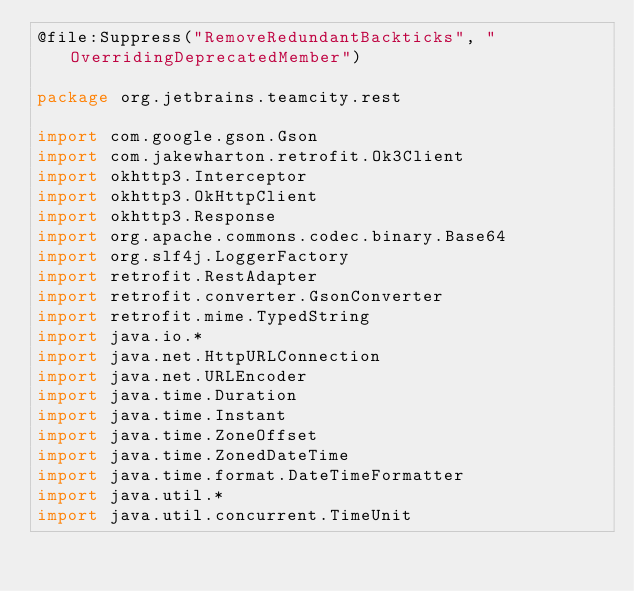<code> <loc_0><loc_0><loc_500><loc_500><_Kotlin_>@file:Suppress("RemoveRedundantBackticks", "OverridingDeprecatedMember")

package org.jetbrains.teamcity.rest

import com.google.gson.Gson
import com.jakewharton.retrofit.Ok3Client
import okhttp3.Interceptor
import okhttp3.OkHttpClient
import okhttp3.Response
import org.apache.commons.codec.binary.Base64
import org.slf4j.LoggerFactory
import retrofit.RestAdapter
import retrofit.converter.GsonConverter
import retrofit.mime.TypedString
import java.io.*
import java.net.HttpURLConnection
import java.net.URLEncoder
import java.time.Duration
import java.time.Instant
import java.time.ZoneOffset
import java.time.ZonedDateTime
import java.time.format.DateTimeFormatter
import java.util.*
import java.util.concurrent.TimeUnit</code> 